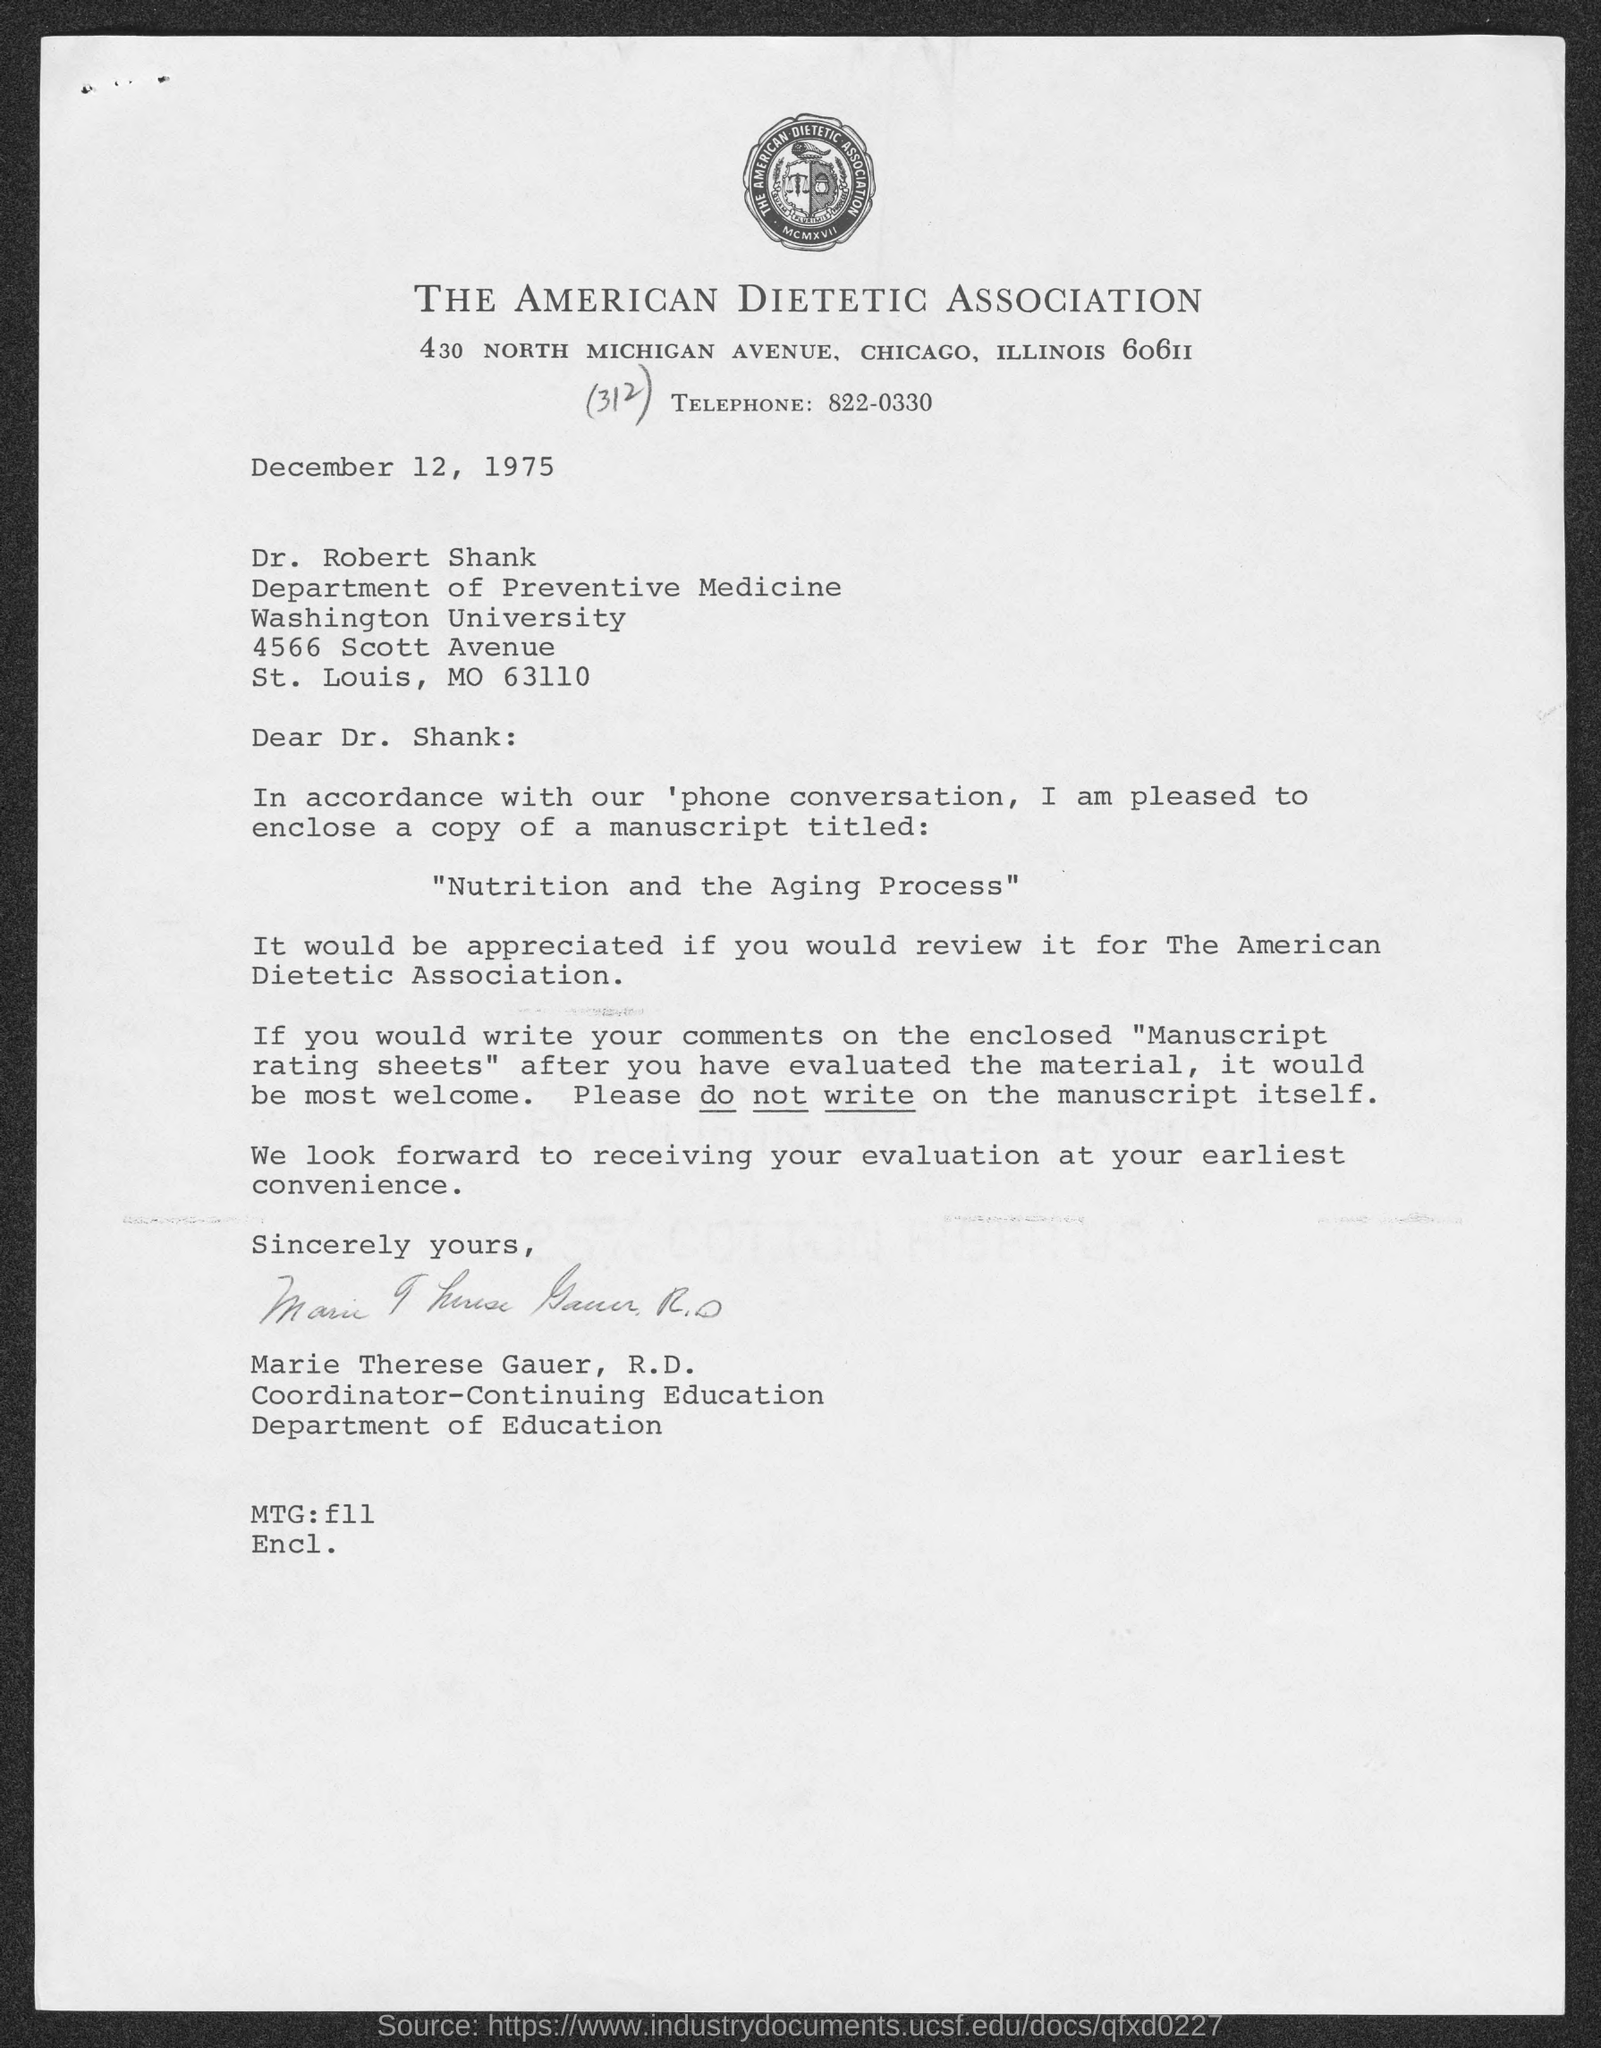Specify some key components in this picture. The Magic: The Gathering field contains information about the values of the fields f11 through f19. The title of the document is "The American Dietetic Association". The telephone number is 822-0330. 